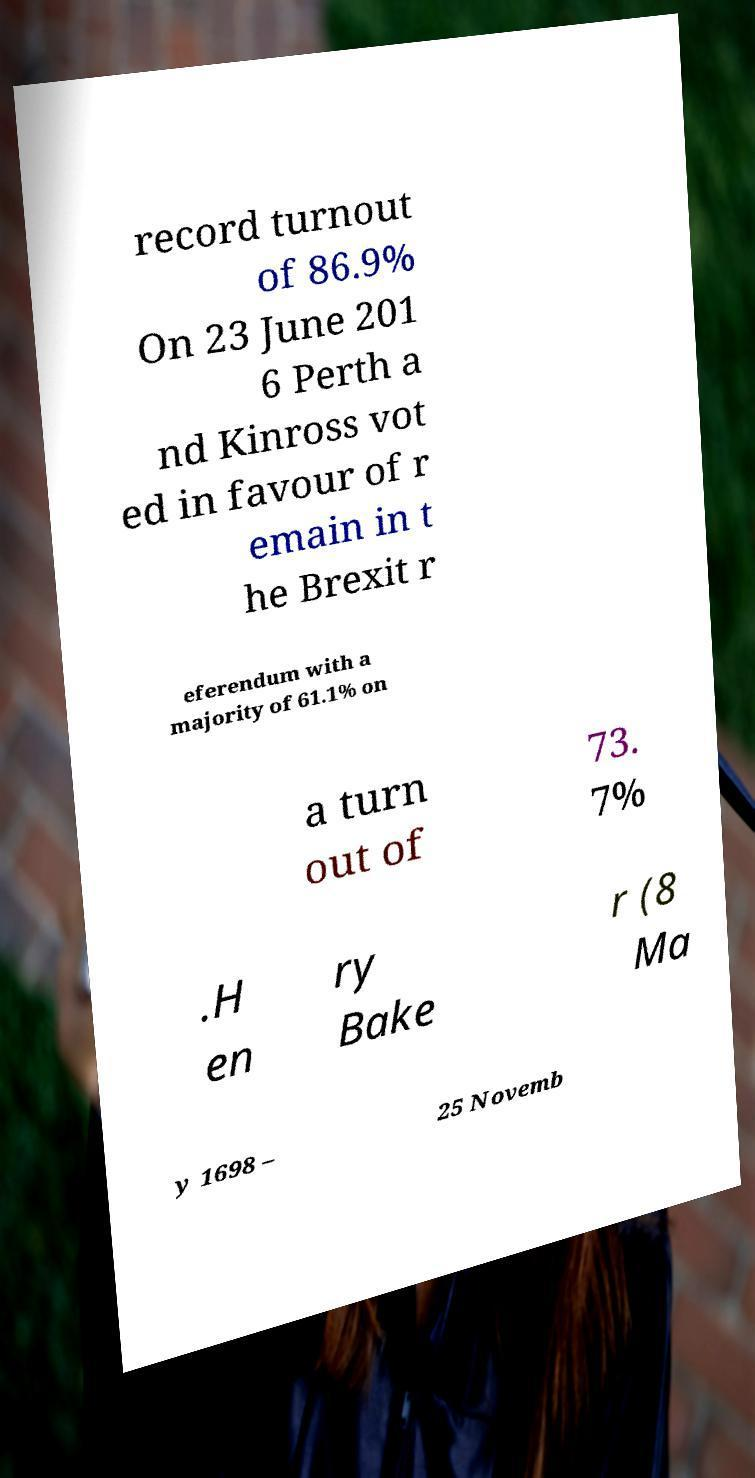Please read and relay the text visible in this image. What does it say? record turnout of 86.9% On 23 June 201 6 Perth a nd Kinross vot ed in favour of r emain in t he Brexit r eferendum with a majority of 61.1% on a turn out of 73. 7% .H en ry Bake r (8 Ma y 1698 – 25 Novemb 